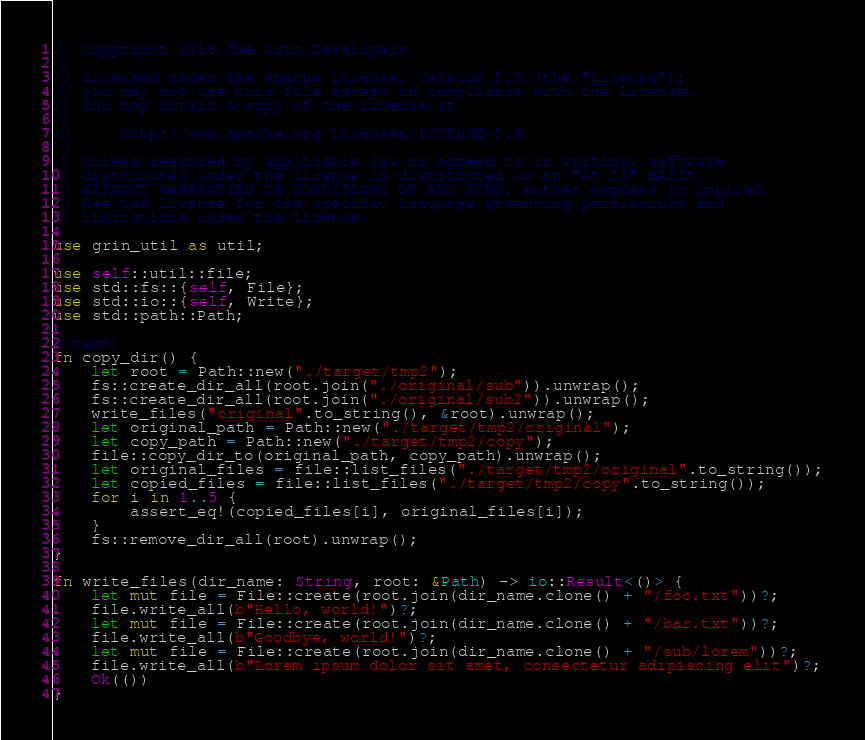<code> <loc_0><loc_0><loc_500><loc_500><_Rust_>// Copyright 2018 The Grin Developers
//
// Licensed under the Apache License, Version 2.0 (the "License");
// you may not use this file except in compliance with the License.
// You may obtain a copy of the License at
//
//     http://www.apache.org/licenses/LICENSE-2.0
//
// Unless required by applicable law or agreed to in writing, software
// distributed under the License is distributed on an "AS IS" BASIS,
// WITHOUT WARRANTIES OR CONDITIONS OF ANY KIND, either express or implied.
// See the License for the specific language governing permissions and
// limitations under the License.

use grin_util as util;

use self::util::file;
use std::fs::{self, File};
use std::io::{self, Write};
use std::path::Path;

#[test]
fn copy_dir() {
	let root = Path::new("./target/tmp2");
	fs::create_dir_all(root.join("./original/sub")).unwrap();
	fs::create_dir_all(root.join("./original/sub2")).unwrap();
	write_files("original".to_string(), &root).unwrap();
	let original_path = Path::new("./target/tmp2/original");
	let copy_path = Path::new("./target/tmp2/copy");
	file::copy_dir_to(original_path, copy_path).unwrap();
	let original_files = file::list_files("./target/tmp2/original".to_string());
	let copied_files = file::list_files("./target/tmp2/copy".to_string());
	for i in 1..5 {
		assert_eq!(copied_files[i], original_files[i]);
	}
	fs::remove_dir_all(root).unwrap();
}

fn write_files(dir_name: String, root: &Path) -> io::Result<()> {
	let mut file = File::create(root.join(dir_name.clone() + "/foo.txt"))?;
	file.write_all(b"Hello, world!")?;
	let mut file = File::create(root.join(dir_name.clone() + "/bar.txt"))?;
	file.write_all(b"Goodbye, world!")?;
	let mut file = File::create(root.join(dir_name.clone() + "/sub/lorem"))?;
	file.write_all(b"Lorem ipsum dolor sit amet, consectetur adipiscing elit")?;
	Ok(())
}
</code> 